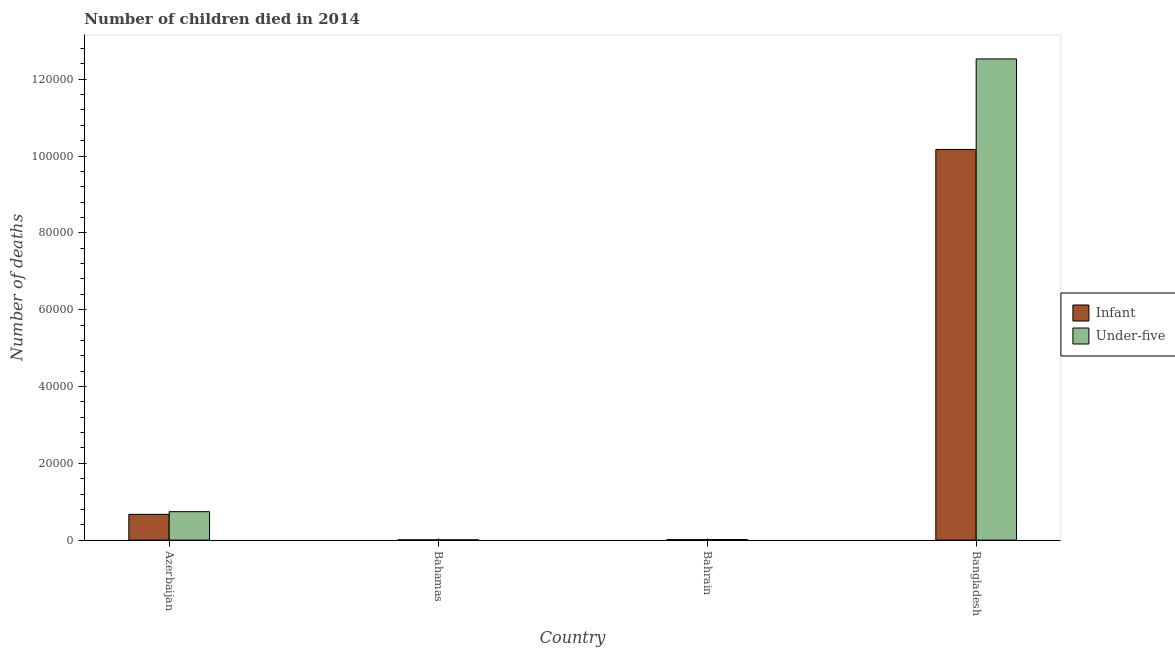How many bars are there on the 2nd tick from the right?
Provide a succinct answer. 2. What is the label of the 1st group of bars from the left?
Provide a succinct answer. Azerbaijan. What is the number of infant deaths in Bahamas?
Your answer should be very brief. 60. Across all countries, what is the maximum number of infant deaths?
Your answer should be very brief. 1.02e+05. Across all countries, what is the minimum number of under-five deaths?
Your answer should be very brief. 73. In which country was the number of infant deaths minimum?
Ensure brevity in your answer.  Bahamas. What is the total number of under-five deaths in the graph?
Give a very brief answer. 1.33e+05. What is the difference between the number of under-five deaths in Azerbaijan and that in Bahamas?
Offer a terse response. 7330. What is the difference between the number of infant deaths in Bangladesh and the number of under-five deaths in Bahrain?
Your answer should be very brief. 1.02e+05. What is the average number of infant deaths per country?
Ensure brevity in your answer.  2.72e+04. What is the difference between the number of under-five deaths and number of infant deaths in Bahamas?
Your answer should be very brief. 13. In how many countries, is the number of infant deaths greater than 112000 ?
Offer a very short reply. 0. What is the ratio of the number of under-five deaths in Bahamas to that in Bahrain?
Give a very brief answer. 0.51. Is the number of infant deaths in Bahrain less than that in Bangladesh?
Provide a short and direct response. Yes. What is the difference between the highest and the second highest number of infant deaths?
Your answer should be very brief. 9.50e+04. What is the difference between the highest and the lowest number of under-five deaths?
Make the answer very short. 1.25e+05. Is the sum of the number of infant deaths in Azerbaijan and Bahrain greater than the maximum number of under-five deaths across all countries?
Provide a short and direct response. No. What does the 1st bar from the left in Bahamas represents?
Give a very brief answer. Infant. What does the 2nd bar from the right in Bahamas represents?
Your response must be concise. Infant. How many bars are there?
Provide a short and direct response. 8. How many countries are there in the graph?
Offer a very short reply. 4. Does the graph contain any zero values?
Keep it short and to the point. No. Does the graph contain grids?
Keep it short and to the point. No. How are the legend labels stacked?
Provide a succinct answer. Vertical. What is the title of the graph?
Provide a succinct answer. Number of children died in 2014. Does "Underweight" appear as one of the legend labels in the graph?
Give a very brief answer. No. What is the label or title of the Y-axis?
Offer a very short reply. Number of deaths. What is the Number of deaths of Infant in Azerbaijan?
Provide a succinct answer. 6706. What is the Number of deaths in Under-five in Azerbaijan?
Make the answer very short. 7403. What is the Number of deaths of Under-five in Bahamas?
Give a very brief answer. 73. What is the Number of deaths of Infant in Bahrain?
Your answer should be very brief. 123. What is the Number of deaths in Under-five in Bahrain?
Your answer should be very brief. 142. What is the Number of deaths of Infant in Bangladesh?
Your answer should be very brief. 1.02e+05. What is the Number of deaths in Under-five in Bangladesh?
Ensure brevity in your answer.  1.25e+05. Across all countries, what is the maximum Number of deaths in Infant?
Keep it short and to the point. 1.02e+05. Across all countries, what is the maximum Number of deaths of Under-five?
Your answer should be very brief. 1.25e+05. Across all countries, what is the minimum Number of deaths of Infant?
Your answer should be very brief. 60. Across all countries, what is the minimum Number of deaths of Under-five?
Provide a succinct answer. 73. What is the total Number of deaths in Infant in the graph?
Keep it short and to the point. 1.09e+05. What is the total Number of deaths of Under-five in the graph?
Provide a succinct answer. 1.33e+05. What is the difference between the Number of deaths of Infant in Azerbaijan and that in Bahamas?
Provide a short and direct response. 6646. What is the difference between the Number of deaths in Under-five in Azerbaijan and that in Bahamas?
Provide a short and direct response. 7330. What is the difference between the Number of deaths of Infant in Azerbaijan and that in Bahrain?
Ensure brevity in your answer.  6583. What is the difference between the Number of deaths of Under-five in Azerbaijan and that in Bahrain?
Your answer should be very brief. 7261. What is the difference between the Number of deaths of Infant in Azerbaijan and that in Bangladesh?
Keep it short and to the point. -9.50e+04. What is the difference between the Number of deaths of Under-five in Azerbaijan and that in Bangladesh?
Offer a terse response. -1.18e+05. What is the difference between the Number of deaths in Infant in Bahamas and that in Bahrain?
Your answer should be compact. -63. What is the difference between the Number of deaths of Under-five in Bahamas and that in Bahrain?
Give a very brief answer. -69. What is the difference between the Number of deaths of Infant in Bahamas and that in Bangladesh?
Your answer should be very brief. -1.02e+05. What is the difference between the Number of deaths in Under-five in Bahamas and that in Bangladesh?
Offer a terse response. -1.25e+05. What is the difference between the Number of deaths in Infant in Bahrain and that in Bangladesh?
Provide a short and direct response. -1.02e+05. What is the difference between the Number of deaths in Under-five in Bahrain and that in Bangladesh?
Provide a short and direct response. -1.25e+05. What is the difference between the Number of deaths in Infant in Azerbaijan and the Number of deaths in Under-five in Bahamas?
Make the answer very short. 6633. What is the difference between the Number of deaths of Infant in Azerbaijan and the Number of deaths of Under-five in Bahrain?
Provide a succinct answer. 6564. What is the difference between the Number of deaths of Infant in Azerbaijan and the Number of deaths of Under-five in Bangladesh?
Your response must be concise. -1.19e+05. What is the difference between the Number of deaths of Infant in Bahamas and the Number of deaths of Under-five in Bahrain?
Your answer should be compact. -82. What is the difference between the Number of deaths of Infant in Bahamas and the Number of deaths of Under-five in Bangladesh?
Offer a very short reply. -1.25e+05. What is the difference between the Number of deaths in Infant in Bahrain and the Number of deaths in Under-five in Bangladesh?
Ensure brevity in your answer.  -1.25e+05. What is the average Number of deaths of Infant per country?
Provide a short and direct response. 2.72e+04. What is the average Number of deaths of Under-five per country?
Offer a very short reply. 3.32e+04. What is the difference between the Number of deaths of Infant and Number of deaths of Under-five in Azerbaijan?
Make the answer very short. -697. What is the difference between the Number of deaths of Infant and Number of deaths of Under-five in Bahamas?
Give a very brief answer. -13. What is the difference between the Number of deaths of Infant and Number of deaths of Under-five in Bahrain?
Make the answer very short. -19. What is the difference between the Number of deaths of Infant and Number of deaths of Under-five in Bangladesh?
Give a very brief answer. -2.36e+04. What is the ratio of the Number of deaths in Infant in Azerbaijan to that in Bahamas?
Give a very brief answer. 111.77. What is the ratio of the Number of deaths of Under-five in Azerbaijan to that in Bahamas?
Your response must be concise. 101.41. What is the ratio of the Number of deaths in Infant in Azerbaijan to that in Bahrain?
Ensure brevity in your answer.  54.52. What is the ratio of the Number of deaths in Under-five in Azerbaijan to that in Bahrain?
Offer a very short reply. 52.13. What is the ratio of the Number of deaths of Infant in Azerbaijan to that in Bangladesh?
Ensure brevity in your answer.  0.07. What is the ratio of the Number of deaths of Under-five in Azerbaijan to that in Bangladesh?
Offer a terse response. 0.06. What is the ratio of the Number of deaths in Infant in Bahamas to that in Bahrain?
Make the answer very short. 0.49. What is the ratio of the Number of deaths of Under-five in Bahamas to that in Bahrain?
Provide a succinct answer. 0.51. What is the ratio of the Number of deaths in Infant in Bahamas to that in Bangladesh?
Ensure brevity in your answer.  0. What is the ratio of the Number of deaths of Under-five in Bahamas to that in Bangladesh?
Provide a short and direct response. 0. What is the ratio of the Number of deaths of Infant in Bahrain to that in Bangladesh?
Provide a short and direct response. 0. What is the ratio of the Number of deaths in Under-five in Bahrain to that in Bangladesh?
Your response must be concise. 0. What is the difference between the highest and the second highest Number of deaths of Infant?
Offer a very short reply. 9.50e+04. What is the difference between the highest and the second highest Number of deaths in Under-five?
Keep it short and to the point. 1.18e+05. What is the difference between the highest and the lowest Number of deaths of Infant?
Offer a terse response. 1.02e+05. What is the difference between the highest and the lowest Number of deaths of Under-five?
Offer a terse response. 1.25e+05. 